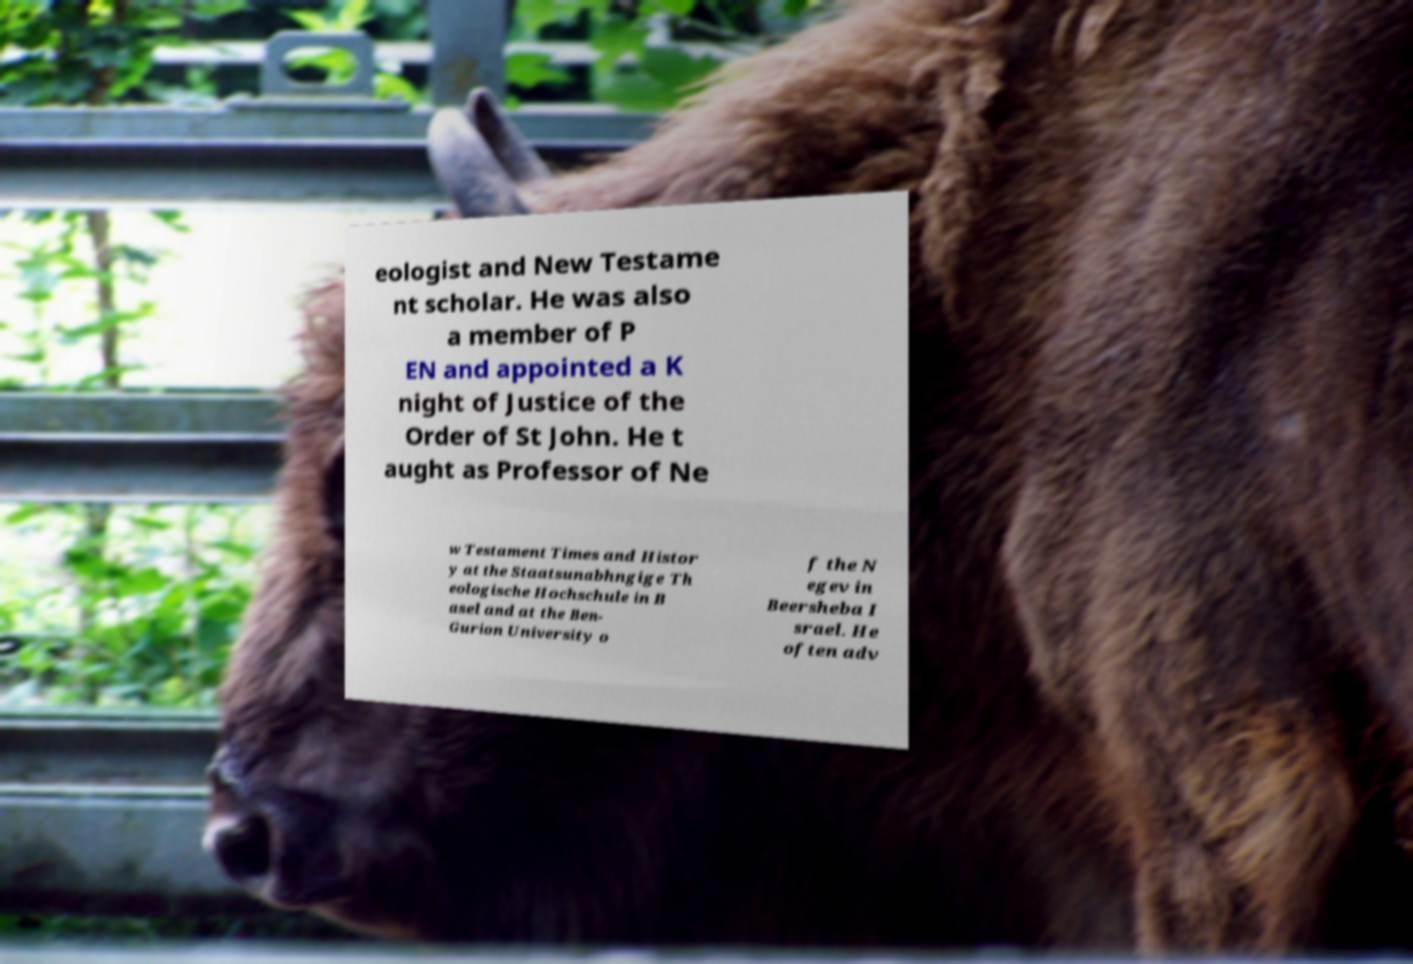Please identify and transcribe the text found in this image. eologist and New Testame nt scholar. He was also a member of P EN and appointed a K night of Justice of the Order of St John. He t aught as Professor of Ne w Testament Times and Histor y at the Staatsunabhngige Th eologische Hochschule in B asel and at the Ben- Gurion University o f the N egev in Beersheba I srael. He often adv 